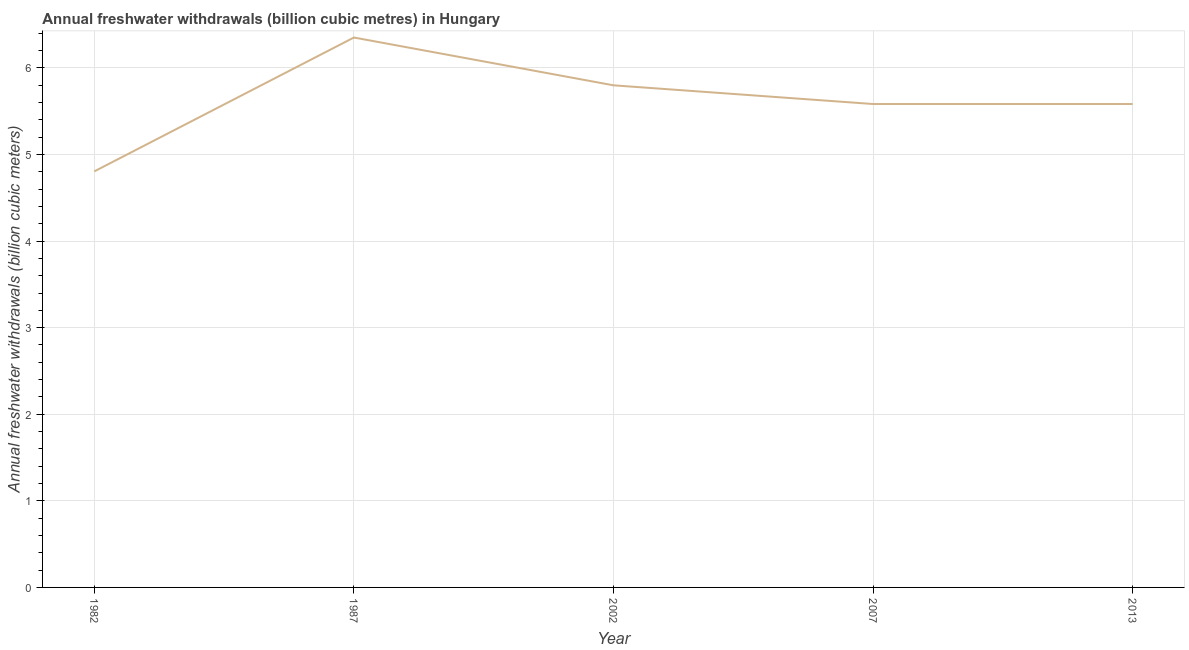What is the annual freshwater withdrawals in 2013?
Offer a terse response. 5.58. Across all years, what is the maximum annual freshwater withdrawals?
Your response must be concise. 6.35. Across all years, what is the minimum annual freshwater withdrawals?
Your answer should be compact. 4.8. In which year was the annual freshwater withdrawals minimum?
Your response must be concise. 1982. What is the sum of the annual freshwater withdrawals?
Your response must be concise. 28.12. What is the difference between the annual freshwater withdrawals in 2002 and 2007?
Your answer should be compact. 0.22. What is the average annual freshwater withdrawals per year?
Provide a short and direct response. 5.62. What is the median annual freshwater withdrawals?
Make the answer very short. 5.58. What is the ratio of the annual freshwater withdrawals in 2002 to that in 2007?
Your answer should be very brief. 1.04. Is the annual freshwater withdrawals in 1982 less than that in 2013?
Make the answer very short. Yes. What is the difference between the highest and the second highest annual freshwater withdrawals?
Ensure brevity in your answer.  0.55. What is the difference between the highest and the lowest annual freshwater withdrawals?
Make the answer very short. 1.55. Does the annual freshwater withdrawals monotonically increase over the years?
Make the answer very short. No. How many years are there in the graph?
Offer a terse response. 5. What is the difference between two consecutive major ticks on the Y-axis?
Your answer should be very brief. 1. Are the values on the major ticks of Y-axis written in scientific E-notation?
Your answer should be compact. No. What is the title of the graph?
Your response must be concise. Annual freshwater withdrawals (billion cubic metres) in Hungary. What is the label or title of the X-axis?
Your response must be concise. Year. What is the label or title of the Y-axis?
Offer a terse response. Annual freshwater withdrawals (billion cubic meters). What is the Annual freshwater withdrawals (billion cubic meters) of 1982?
Your answer should be very brief. 4.8. What is the Annual freshwater withdrawals (billion cubic meters) of 1987?
Provide a short and direct response. 6.35. What is the Annual freshwater withdrawals (billion cubic meters) of 2002?
Provide a short and direct response. 5.8. What is the Annual freshwater withdrawals (billion cubic meters) of 2007?
Provide a short and direct response. 5.58. What is the Annual freshwater withdrawals (billion cubic meters) in 2013?
Your response must be concise. 5.58. What is the difference between the Annual freshwater withdrawals (billion cubic meters) in 1982 and 1987?
Provide a short and direct response. -1.55. What is the difference between the Annual freshwater withdrawals (billion cubic meters) in 1982 and 2002?
Provide a succinct answer. -0.99. What is the difference between the Annual freshwater withdrawals (billion cubic meters) in 1982 and 2007?
Offer a very short reply. -0.78. What is the difference between the Annual freshwater withdrawals (billion cubic meters) in 1982 and 2013?
Make the answer very short. -0.78. What is the difference between the Annual freshwater withdrawals (billion cubic meters) in 1987 and 2002?
Your answer should be very brief. 0.55. What is the difference between the Annual freshwater withdrawals (billion cubic meters) in 1987 and 2007?
Provide a short and direct response. 0.77. What is the difference between the Annual freshwater withdrawals (billion cubic meters) in 1987 and 2013?
Give a very brief answer. 0.77. What is the difference between the Annual freshwater withdrawals (billion cubic meters) in 2002 and 2007?
Provide a succinct answer. 0.22. What is the difference between the Annual freshwater withdrawals (billion cubic meters) in 2002 and 2013?
Provide a succinct answer. 0.22. What is the difference between the Annual freshwater withdrawals (billion cubic meters) in 2007 and 2013?
Make the answer very short. 0. What is the ratio of the Annual freshwater withdrawals (billion cubic meters) in 1982 to that in 1987?
Your answer should be compact. 0.76. What is the ratio of the Annual freshwater withdrawals (billion cubic meters) in 1982 to that in 2002?
Ensure brevity in your answer.  0.83. What is the ratio of the Annual freshwater withdrawals (billion cubic meters) in 1982 to that in 2007?
Make the answer very short. 0.86. What is the ratio of the Annual freshwater withdrawals (billion cubic meters) in 1982 to that in 2013?
Your response must be concise. 0.86. What is the ratio of the Annual freshwater withdrawals (billion cubic meters) in 1987 to that in 2002?
Your answer should be compact. 1.09. What is the ratio of the Annual freshwater withdrawals (billion cubic meters) in 1987 to that in 2007?
Your answer should be compact. 1.14. What is the ratio of the Annual freshwater withdrawals (billion cubic meters) in 1987 to that in 2013?
Provide a succinct answer. 1.14. What is the ratio of the Annual freshwater withdrawals (billion cubic meters) in 2002 to that in 2007?
Your answer should be compact. 1.04. What is the ratio of the Annual freshwater withdrawals (billion cubic meters) in 2002 to that in 2013?
Make the answer very short. 1.04. 